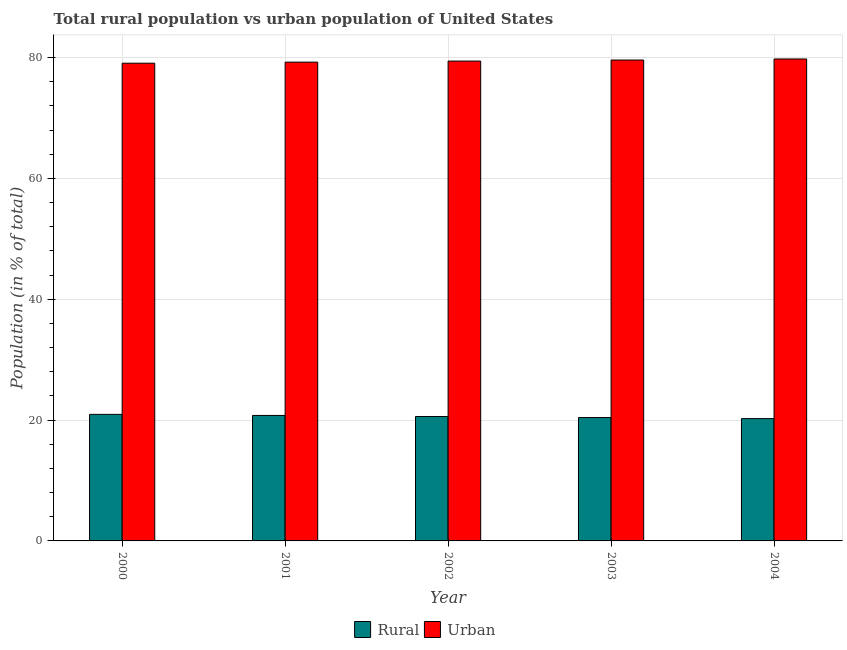How many different coloured bars are there?
Keep it short and to the point. 2. How many groups of bars are there?
Provide a succinct answer. 5. Are the number of bars on each tick of the X-axis equal?
Your answer should be very brief. Yes. How many bars are there on the 5th tick from the right?
Provide a short and direct response. 2. What is the label of the 4th group of bars from the left?
Offer a terse response. 2003. In how many cases, is the number of bars for a given year not equal to the number of legend labels?
Offer a terse response. 0. What is the urban population in 2003?
Keep it short and to the point. 79.58. Across all years, what is the maximum urban population?
Offer a terse response. 79.76. Across all years, what is the minimum urban population?
Your answer should be very brief. 79.06. In which year was the rural population minimum?
Provide a short and direct response. 2004. What is the total rural population in the graph?
Offer a very short reply. 102.96. What is the difference between the urban population in 2000 and that in 2003?
Ensure brevity in your answer.  -0.53. What is the difference between the urban population in 2000 and the rural population in 2001?
Offer a very short reply. -0.18. What is the average rural population per year?
Your answer should be compact. 20.59. In the year 2001, what is the difference between the rural population and urban population?
Make the answer very short. 0. In how many years, is the urban population greater than 56 %?
Your response must be concise. 5. What is the ratio of the rural population in 2002 to that in 2003?
Provide a succinct answer. 1.01. Is the rural population in 2002 less than that in 2003?
Your answer should be compact. No. What is the difference between the highest and the second highest urban population?
Provide a short and direct response. 0.17. What is the difference between the highest and the lowest urban population?
Provide a short and direct response. 0.7. Is the sum of the urban population in 2000 and 2002 greater than the maximum rural population across all years?
Your answer should be very brief. Yes. What does the 2nd bar from the left in 2001 represents?
Your answer should be compact. Urban. What does the 2nd bar from the right in 2002 represents?
Make the answer very short. Rural. How many bars are there?
Your answer should be compact. 10. Does the graph contain grids?
Ensure brevity in your answer.  Yes. Where does the legend appear in the graph?
Make the answer very short. Bottom center. What is the title of the graph?
Your answer should be very brief. Total rural population vs urban population of United States. What is the label or title of the Y-axis?
Offer a terse response. Population (in % of total). What is the Population (in % of total) of Rural in 2000?
Offer a terse response. 20.94. What is the Population (in % of total) in Urban in 2000?
Give a very brief answer. 79.06. What is the Population (in % of total) in Rural in 2001?
Your answer should be very brief. 20.77. What is the Population (in % of total) of Urban in 2001?
Offer a terse response. 79.23. What is the Population (in % of total) in Rural in 2002?
Ensure brevity in your answer.  20.59. What is the Population (in % of total) in Urban in 2002?
Keep it short and to the point. 79.41. What is the Population (in % of total) in Rural in 2003?
Give a very brief answer. 20.42. What is the Population (in % of total) in Urban in 2003?
Offer a terse response. 79.58. What is the Population (in % of total) in Rural in 2004?
Provide a short and direct response. 20.24. What is the Population (in % of total) in Urban in 2004?
Offer a terse response. 79.76. Across all years, what is the maximum Population (in % of total) in Rural?
Give a very brief answer. 20.94. Across all years, what is the maximum Population (in % of total) of Urban?
Provide a succinct answer. 79.76. Across all years, what is the minimum Population (in % of total) in Rural?
Ensure brevity in your answer.  20.24. Across all years, what is the minimum Population (in % of total) in Urban?
Give a very brief answer. 79.06. What is the total Population (in % of total) in Rural in the graph?
Offer a terse response. 102.96. What is the total Population (in % of total) of Urban in the graph?
Provide a short and direct response. 397.04. What is the difference between the Population (in % of total) in Rural in 2000 and that in 2001?
Ensure brevity in your answer.  0.18. What is the difference between the Population (in % of total) of Urban in 2000 and that in 2001?
Your response must be concise. -0.18. What is the difference between the Population (in % of total) of Rural in 2000 and that in 2002?
Make the answer very short. 0.35. What is the difference between the Population (in % of total) of Urban in 2000 and that in 2002?
Your answer should be very brief. -0.35. What is the difference between the Population (in % of total) of Rural in 2000 and that in 2003?
Your answer should be compact. 0.53. What is the difference between the Population (in % of total) of Urban in 2000 and that in 2003?
Your response must be concise. -0.53. What is the difference between the Population (in % of total) of Rural in 2000 and that in 2004?
Your response must be concise. 0.7. What is the difference between the Population (in % of total) in Rural in 2001 and that in 2002?
Offer a terse response. 0.17. What is the difference between the Population (in % of total) in Urban in 2001 and that in 2002?
Your answer should be compact. -0.17. What is the difference between the Population (in % of total) in Rural in 2001 and that in 2003?
Provide a succinct answer. 0.35. What is the difference between the Population (in % of total) in Urban in 2001 and that in 2003?
Ensure brevity in your answer.  -0.35. What is the difference between the Population (in % of total) of Rural in 2001 and that in 2004?
Make the answer very short. 0.52. What is the difference between the Population (in % of total) of Urban in 2001 and that in 2004?
Your response must be concise. -0.52. What is the difference between the Population (in % of total) of Rural in 2002 and that in 2003?
Make the answer very short. 0.17. What is the difference between the Population (in % of total) in Urban in 2002 and that in 2003?
Your answer should be very brief. -0.17. What is the difference between the Population (in % of total) in Rural in 2002 and that in 2004?
Give a very brief answer. 0.35. What is the difference between the Population (in % of total) in Urban in 2002 and that in 2004?
Your answer should be compact. -0.35. What is the difference between the Population (in % of total) in Rural in 2003 and that in 2004?
Your response must be concise. 0.17. What is the difference between the Population (in % of total) in Urban in 2003 and that in 2004?
Provide a short and direct response. -0.17. What is the difference between the Population (in % of total) of Rural in 2000 and the Population (in % of total) of Urban in 2001?
Your response must be concise. -58.29. What is the difference between the Population (in % of total) of Rural in 2000 and the Population (in % of total) of Urban in 2002?
Give a very brief answer. -58.47. What is the difference between the Population (in % of total) in Rural in 2000 and the Population (in % of total) in Urban in 2003?
Offer a very short reply. -58.64. What is the difference between the Population (in % of total) of Rural in 2000 and the Population (in % of total) of Urban in 2004?
Make the answer very short. -58.81. What is the difference between the Population (in % of total) of Rural in 2001 and the Population (in % of total) of Urban in 2002?
Keep it short and to the point. -58.64. What is the difference between the Population (in % of total) of Rural in 2001 and the Population (in % of total) of Urban in 2003?
Provide a succinct answer. -58.82. What is the difference between the Population (in % of total) of Rural in 2001 and the Population (in % of total) of Urban in 2004?
Offer a very short reply. -58.99. What is the difference between the Population (in % of total) of Rural in 2002 and the Population (in % of total) of Urban in 2003?
Provide a short and direct response. -58.99. What is the difference between the Population (in % of total) of Rural in 2002 and the Population (in % of total) of Urban in 2004?
Keep it short and to the point. -59.17. What is the difference between the Population (in % of total) in Rural in 2003 and the Population (in % of total) in Urban in 2004?
Your answer should be compact. -59.34. What is the average Population (in % of total) of Rural per year?
Your answer should be compact. 20.59. What is the average Population (in % of total) of Urban per year?
Your answer should be very brief. 79.41. In the year 2000, what is the difference between the Population (in % of total) of Rural and Population (in % of total) of Urban?
Keep it short and to the point. -58.11. In the year 2001, what is the difference between the Population (in % of total) in Rural and Population (in % of total) in Urban?
Provide a succinct answer. -58.47. In the year 2002, what is the difference between the Population (in % of total) of Rural and Population (in % of total) of Urban?
Provide a succinct answer. -58.82. In the year 2003, what is the difference between the Population (in % of total) in Rural and Population (in % of total) in Urban?
Your answer should be very brief. -59.17. In the year 2004, what is the difference between the Population (in % of total) in Rural and Population (in % of total) in Urban?
Provide a succinct answer. -59.51. What is the ratio of the Population (in % of total) of Rural in 2000 to that in 2001?
Make the answer very short. 1.01. What is the ratio of the Population (in % of total) of Urban in 2000 to that in 2001?
Your answer should be very brief. 1. What is the ratio of the Population (in % of total) of Rural in 2000 to that in 2002?
Offer a very short reply. 1.02. What is the ratio of the Population (in % of total) in Urban in 2000 to that in 2002?
Offer a terse response. 1. What is the ratio of the Population (in % of total) of Rural in 2000 to that in 2003?
Provide a short and direct response. 1.03. What is the ratio of the Population (in % of total) in Rural in 2000 to that in 2004?
Ensure brevity in your answer.  1.03. What is the ratio of the Population (in % of total) in Rural in 2001 to that in 2002?
Give a very brief answer. 1.01. What is the ratio of the Population (in % of total) in Urban in 2001 to that in 2002?
Your answer should be compact. 1. What is the ratio of the Population (in % of total) in Rural in 2001 to that in 2003?
Provide a short and direct response. 1.02. What is the ratio of the Population (in % of total) of Urban in 2001 to that in 2003?
Make the answer very short. 1. What is the ratio of the Population (in % of total) in Rural in 2001 to that in 2004?
Keep it short and to the point. 1.03. What is the ratio of the Population (in % of total) in Rural in 2002 to that in 2003?
Provide a succinct answer. 1.01. What is the ratio of the Population (in % of total) of Rural in 2002 to that in 2004?
Provide a succinct answer. 1.02. What is the ratio of the Population (in % of total) in Urban in 2002 to that in 2004?
Your response must be concise. 1. What is the ratio of the Population (in % of total) of Rural in 2003 to that in 2004?
Ensure brevity in your answer.  1.01. What is the difference between the highest and the second highest Population (in % of total) in Rural?
Keep it short and to the point. 0.18. What is the difference between the highest and the second highest Population (in % of total) in Urban?
Ensure brevity in your answer.  0.17. What is the difference between the highest and the lowest Population (in % of total) in Urban?
Keep it short and to the point. 0.7. 